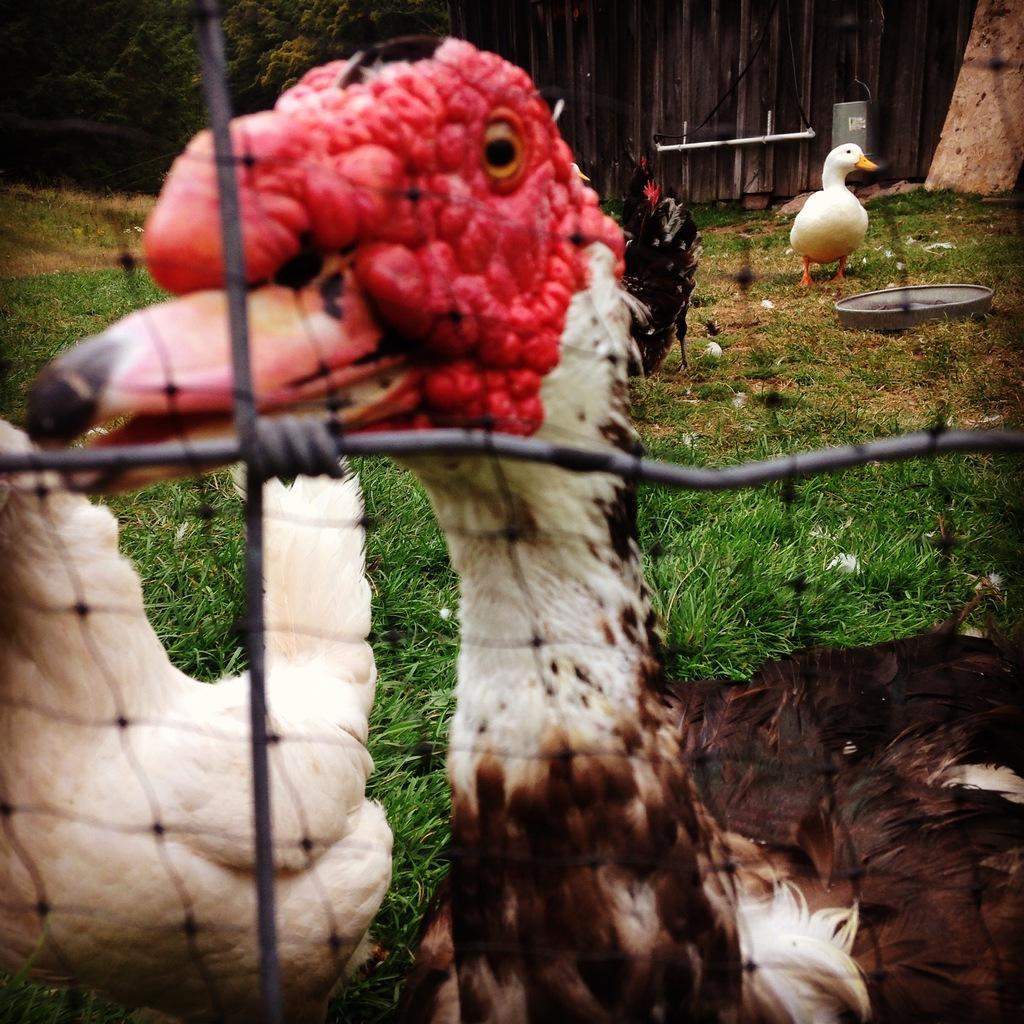How would you summarize this image in a sentence or two? In this image I can see the face of a duck in red color. On the left side there is another bird in white color. This is the grass, on the right side there is a duck standing in white color and there is a bowl at here. At the top there is a wooden fencing. On the left side there are trees. 